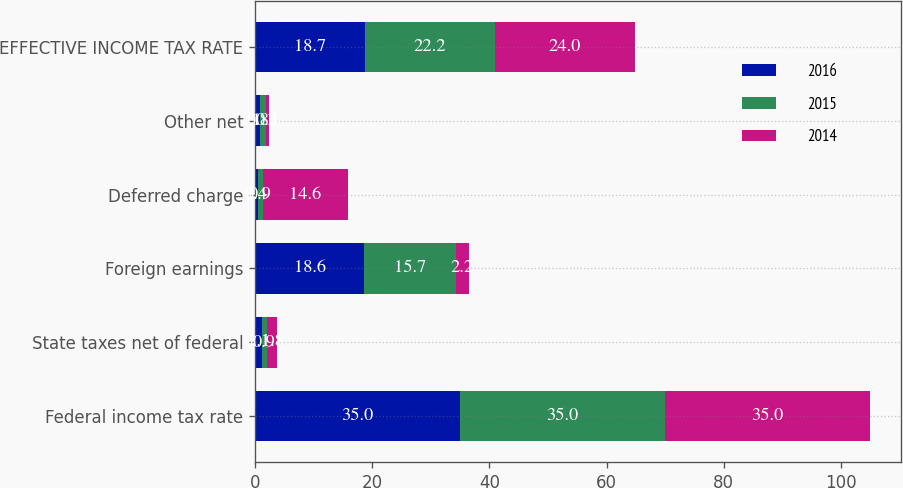<chart> <loc_0><loc_0><loc_500><loc_500><stacked_bar_chart><ecel><fcel>Federal income tax rate<fcel>State taxes net of federal<fcel>Foreign earnings<fcel>Deferred charge<fcel>Other net<fcel>EFFECTIVE INCOME TAX RATE<nl><fcel>2016<fcel>35<fcel>1.1<fcel>18.6<fcel>0.4<fcel>0.8<fcel>18.7<nl><fcel>2015<fcel>35<fcel>0.9<fcel>15.7<fcel>0.9<fcel>1.1<fcel>22.2<nl><fcel>2014<fcel>35<fcel>1.8<fcel>2.2<fcel>14.6<fcel>0.4<fcel>24<nl></chart> 